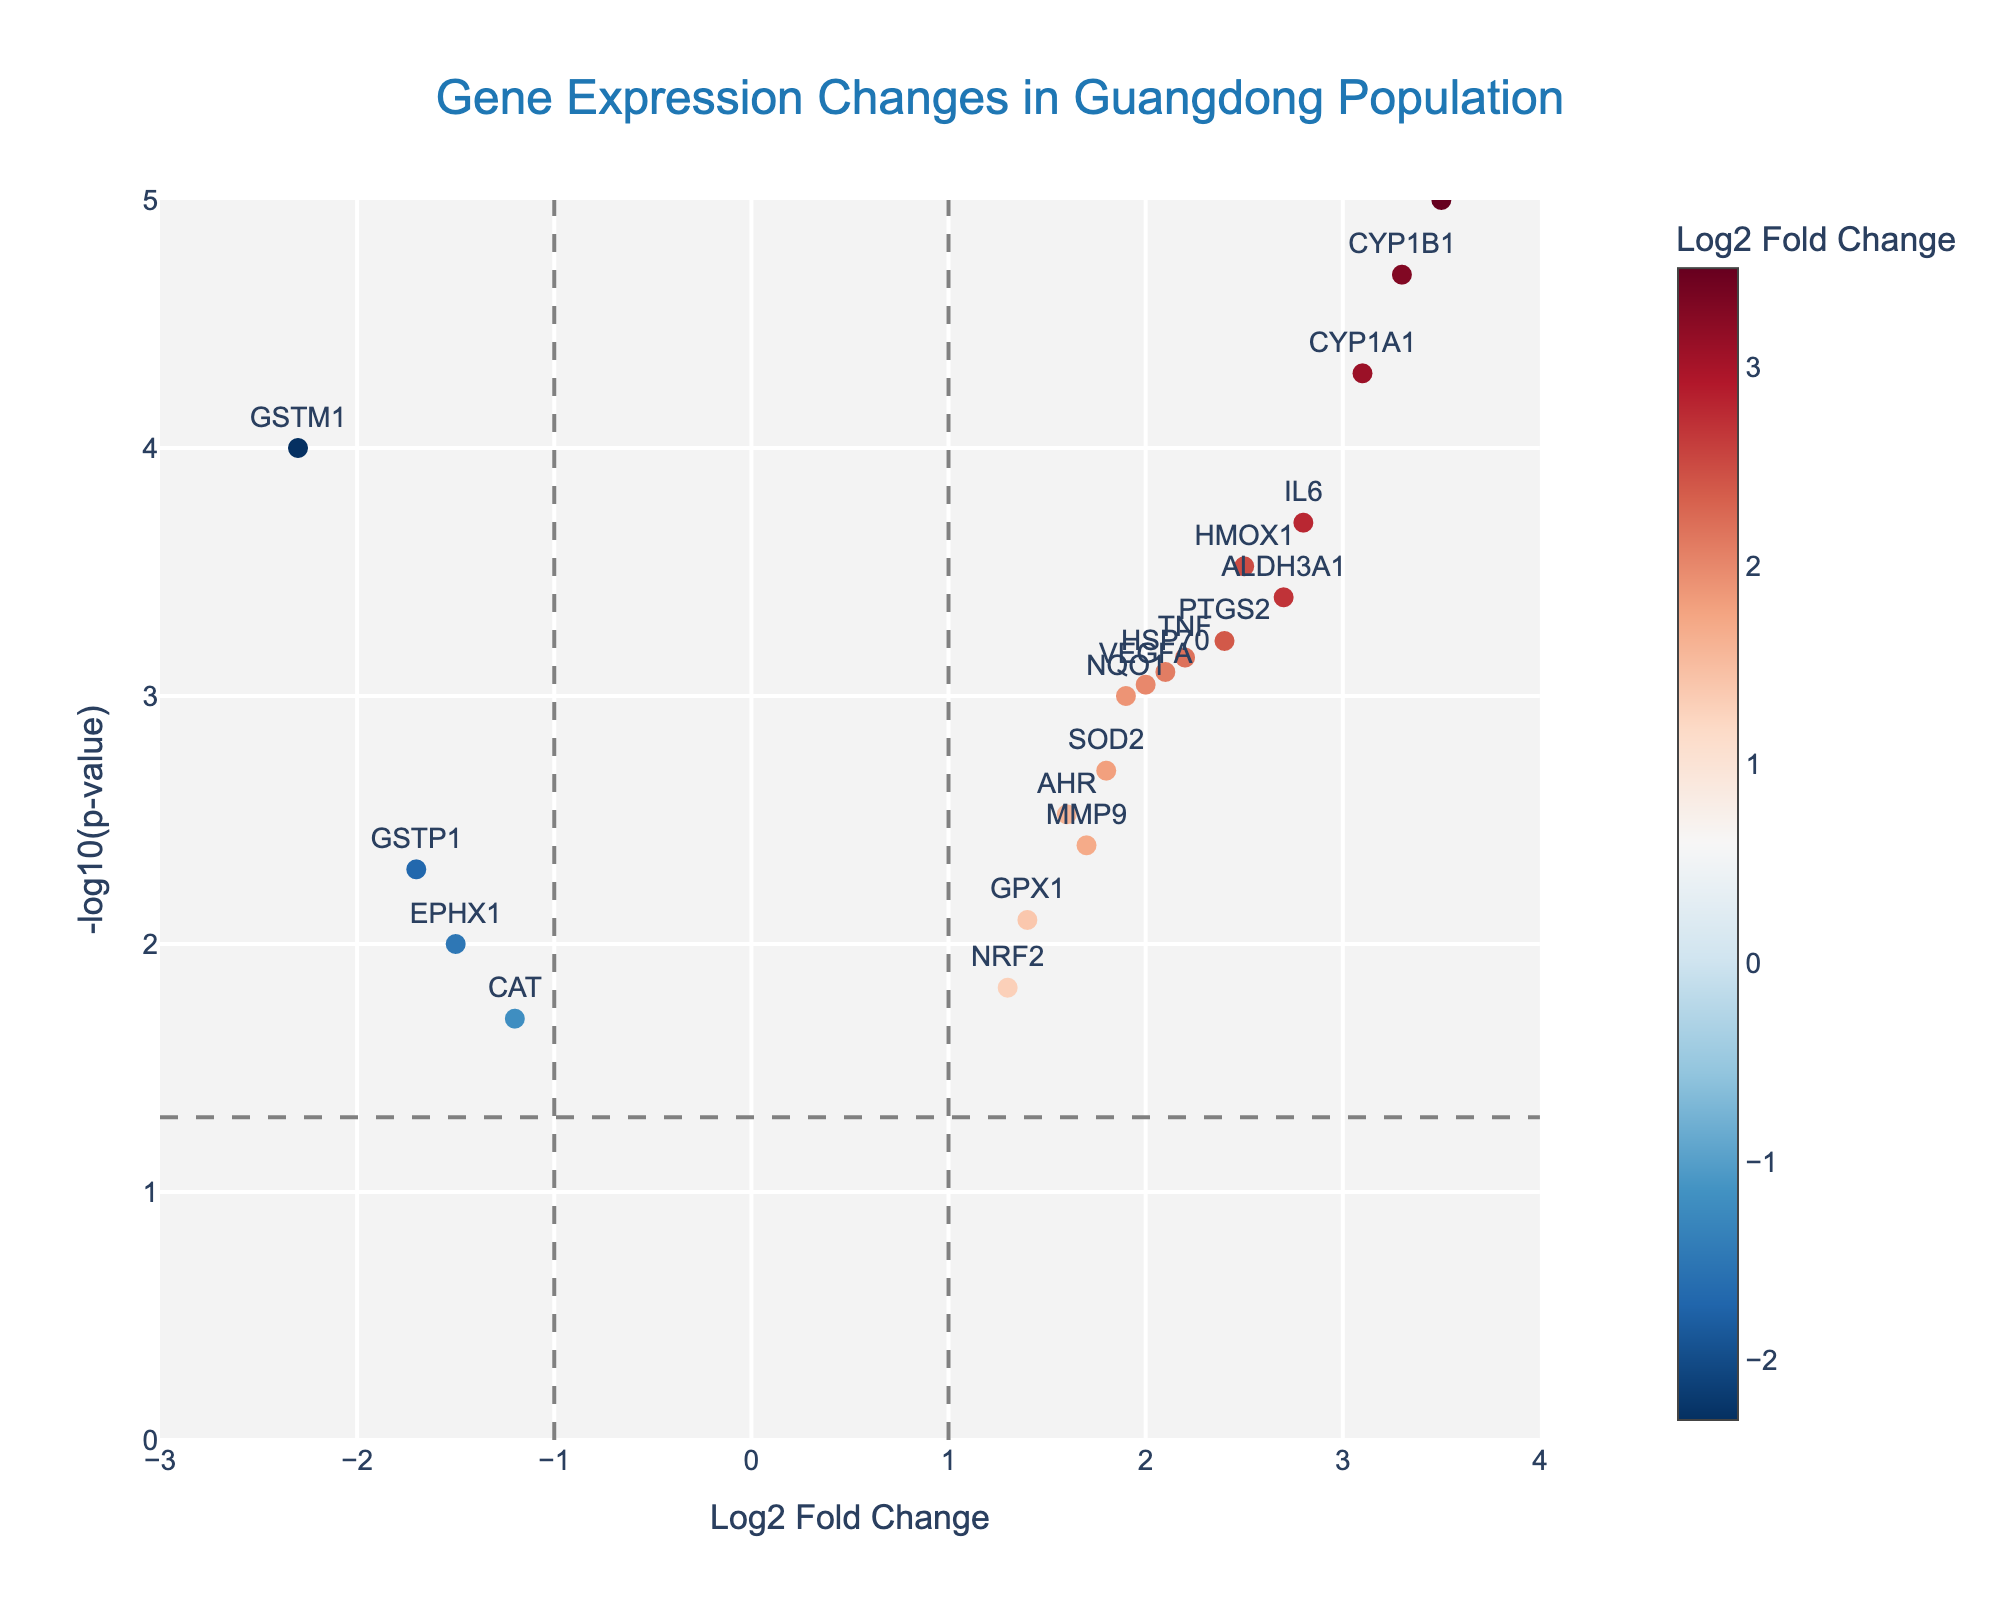How many genes were analyzed in this study? The plot has markers labeled with gene names. Count the total number of unique gene labels visible in the figure.
Answer: 20 What does a higher -log10(p-value) signify in this plot? In the Volcano Plot, -log10(p-value) is on the y-axis. A higher -log10(p-value) means a lower p-value, indicating greater statistical significance.
Answer: Greater statistical significance Which gene has the largest positive Log2 Fold Change? Locate the marker with the highest x-axis value (Log2 Fold Change) in the plot. In this case, the gene with Log2 Fold Change of 3.5 is MT1A.
Answer: MT1A How many genes have a Log2 Fold Change greater than 2? Count the number of markers on the right side of the vertical line at x = 2 in the plot. The genes are CYP1A1, HMOX1, IL6, MT1A, CYP1B1, VEGFA, and PTGS2, making a total of 7 genes.
Answer: 7 What is the relationship between p-value and -log10(p-value)? The -log10(p-value) is plotted on the y-axis, meaning it is the negative logarithm base 10 of the p-value; as p-value decreases, -log10(p-value) increases.
Answer: Inverse relationship Which genes have Log2 Fold Change less than -1 and are statistically significant (p < 0.05)? Identify markers to the left of the vertical line at x = -1 with a y-coordinate (i.e., -log10(p-value)) above the horizontal line, representing p < 0.05. The genes are GSTM1 and GSTP1.
Answer: GSTM1, GSTP1 What does the color of the markers represent in the plot? The color of each marker reflects the Log2 Fold Change value, based on a color gradient shown on the color bar in the plot.
Answer: Log2 Fold Change value Which gene has the smallest p-value in this analysis? Look for the marker with the highest y-axis value, representing the smallest p-value. The gene with the highest -log10(p)value is MT1A.
Answer: MT1A For the gene CYP1A1, what are its Log2 Fold Change and p-value? Find the marker labeled CYP1A1 and hover over it to see its Log2 Fold Change and p-value in the hover text. The values from the plot's marker data are Log2 Fold Change: 3.1 and p-value: 0.00005.
Answer: Log2 Fold Change: 3.1, p-value: 0.00005 